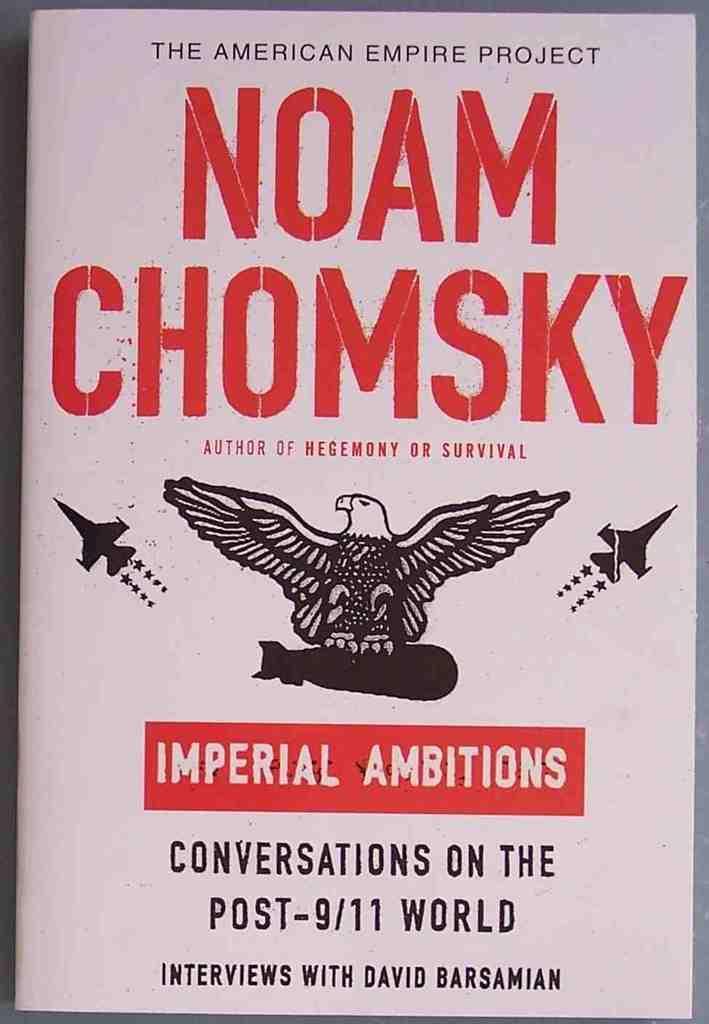In one or two sentences, can you explain what this image depicts? In this picture I can see a poster, there are words, numbers and there are photos of two aircrafts and an eagle, on the poster. 